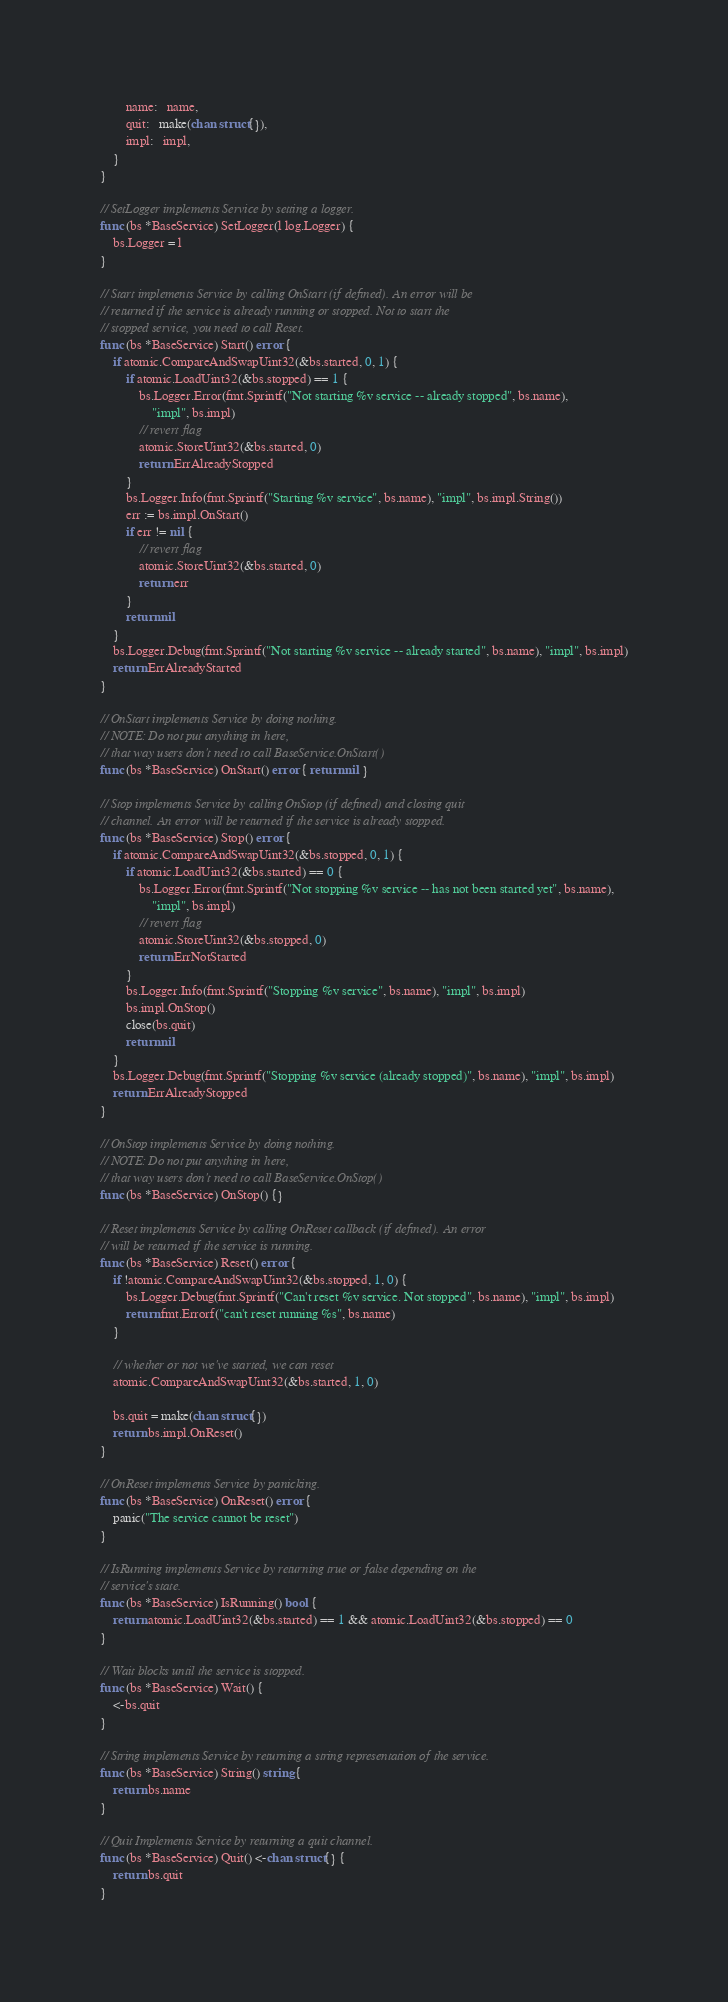<code> <loc_0><loc_0><loc_500><loc_500><_Go_>		name:   name,
		quit:   make(chan struct{}),
		impl:   impl,
	}
}

// SetLogger implements Service by setting a logger.
func (bs *BaseService) SetLogger(l log.Logger) {
	bs.Logger = l
}

// Start implements Service by calling OnStart (if defined). An error will be
// returned if the service is already running or stopped. Not to start the
// stopped service, you need to call Reset.
func (bs *BaseService) Start() error {
	if atomic.CompareAndSwapUint32(&bs.started, 0, 1) {
		if atomic.LoadUint32(&bs.stopped) == 1 {
			bs.Logger.Error(fmt.Sprintf("Not starting %v service -- already stopped", bs.name),
				"impl", bs.impl)
			// revert flag
			atomic.StoreUint32(&bs.started, 0)
			return ErrAlreadyStopped
		}
		bs.Logger.Info(fmt.Sprintf("Starting %v service", bs.name), "impl", bs.impl.String())
		err := bs.impl.OnStart()
		if err != nil {
			// revert flag
			atomic.StoreUint32(&bs.started, 0)
			return err
		}
		return nil
	}
	bs.Logger.Debug(fmt.Sprintf("Not starting %v service -- already started", bs.name), "impl", bs.impl)
	return ErrAlreadyStarted
}

// OnStart implements Service by doing nothing.
// NOTE: Do not put anything in here,
// that way users don't need to call BaseService.OnStart()
func (bs *BaseService) OnStart() error { return nil }

// Stop implements Service by calling OnStop (if defined) and closing quit
// channel. An error will be returned if the service is already stopped.
func (bs *BaseService) Stop() error {
	if atomic.CompareAndSwapUint32(&bs.stopped, 0, 1) {
		if atomic.LoadUint32(&bs.started) == 0 {
			bs.Logger.Error(fmt.Sprintf("Not stopping %v service -- has not been started yet", bs.name),
				"impl", bs.impl)
			// revert flag
			atomic.StoreUint32(&bs.stopped, 0)
			return ErrNotStarted
		}
		bs.Logger.Info(fmt.Sprintf("Stopping %v service", bs.name), "impl", bs.impl)
		bs.impl.OnStop()
		close(bs.quit)
		return nil
	}
	bs.Logger.Debug(fmt.Sprintf("Stopping %v service (already stopped)", bs.name), "impl", bs.impl)
	return ErrAlreadyStopped
}

// OnStop implements Service by doing nothing.
// NOTE: Do not put anything in here,
// that way users don't need to call BaseService.OnStop()
func (bs *BaseService) OnStop() {}

// Reset implements Service by calling OnReset callback (if defined). An error
// will be returned if the service is running.
func (bs *BaseService) Reset() error {
	if !atomic.CompareAndSwapUint32(&bs.stopped, 1, 0) {
		bs.Logger.Debug(fmt.Sprintf("Can't reset %v service. Not stopped", bs.name), "impl", bs.impl)
		return fmt.Errorf("can't reset running %s", bs.name)
	}

	// whether or not we've started, we can reset
	atomic.CompareAndSwapUint32(&bs.started, 1, 0)

	bs.quit = make(chan struct{})
	return bs.impl.OnReset()
}

// OnReset implements Service by panicking.
func (bs *BaseService) OnReset() error {
	panic("The service cannot be reset")
}

// IsRunning implements Service by returning true or false depending on the
// service's state.
func (bs *BaseService) IsRunning() bool {
	return atomic.LoadUint32(&bs.started) == 1 && atomic.LoadUint32(&bs.stopped) == 0
}

// Wait blocks until the service is stopped.
func (bs *BaseService) Wait() {
	<-bs.quit
}

// String implements Service by returning a string representation of the service.
func (bs *BaseService) String() string {
	return bs.name
}

// Quit Implements Service by returning a quit channel.
func (bs *BaseService) Quit() <-chan struct{} {
	return bs.quit
}
</code> 